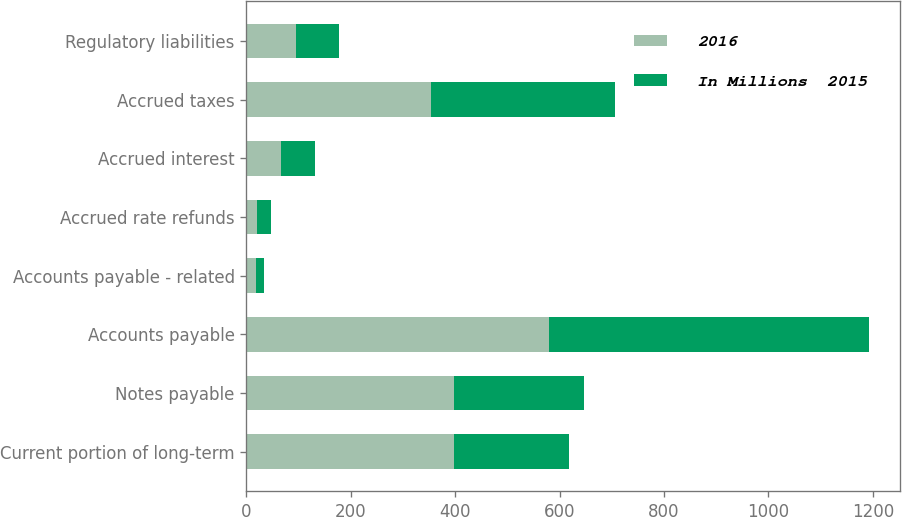<chart> <loc_0><loc_0><loc_500><loc_500><stacked_bar_chart><ecel><fcel>Current portion of long-term<fcel>Notes payable<fcel>Accounts payable<fcel>Accounts payable - related<fcel>Accrued rate refunds<fcel>Accrued interest<fcel>Accrued taxes<fcel>Regulatory liabilities<nl><fcel>2016<fcel>397<fcel>398<fcel>580<fcel>18<fcel>21<fcel>67<fcel>354<fcel>95<nl><fcel>In Millions  2015<fcel>220<fcel>249<fcel>613<fcel>15<fcel>26<fcel>65<fcel>352<fcel>82<nl></chart> 